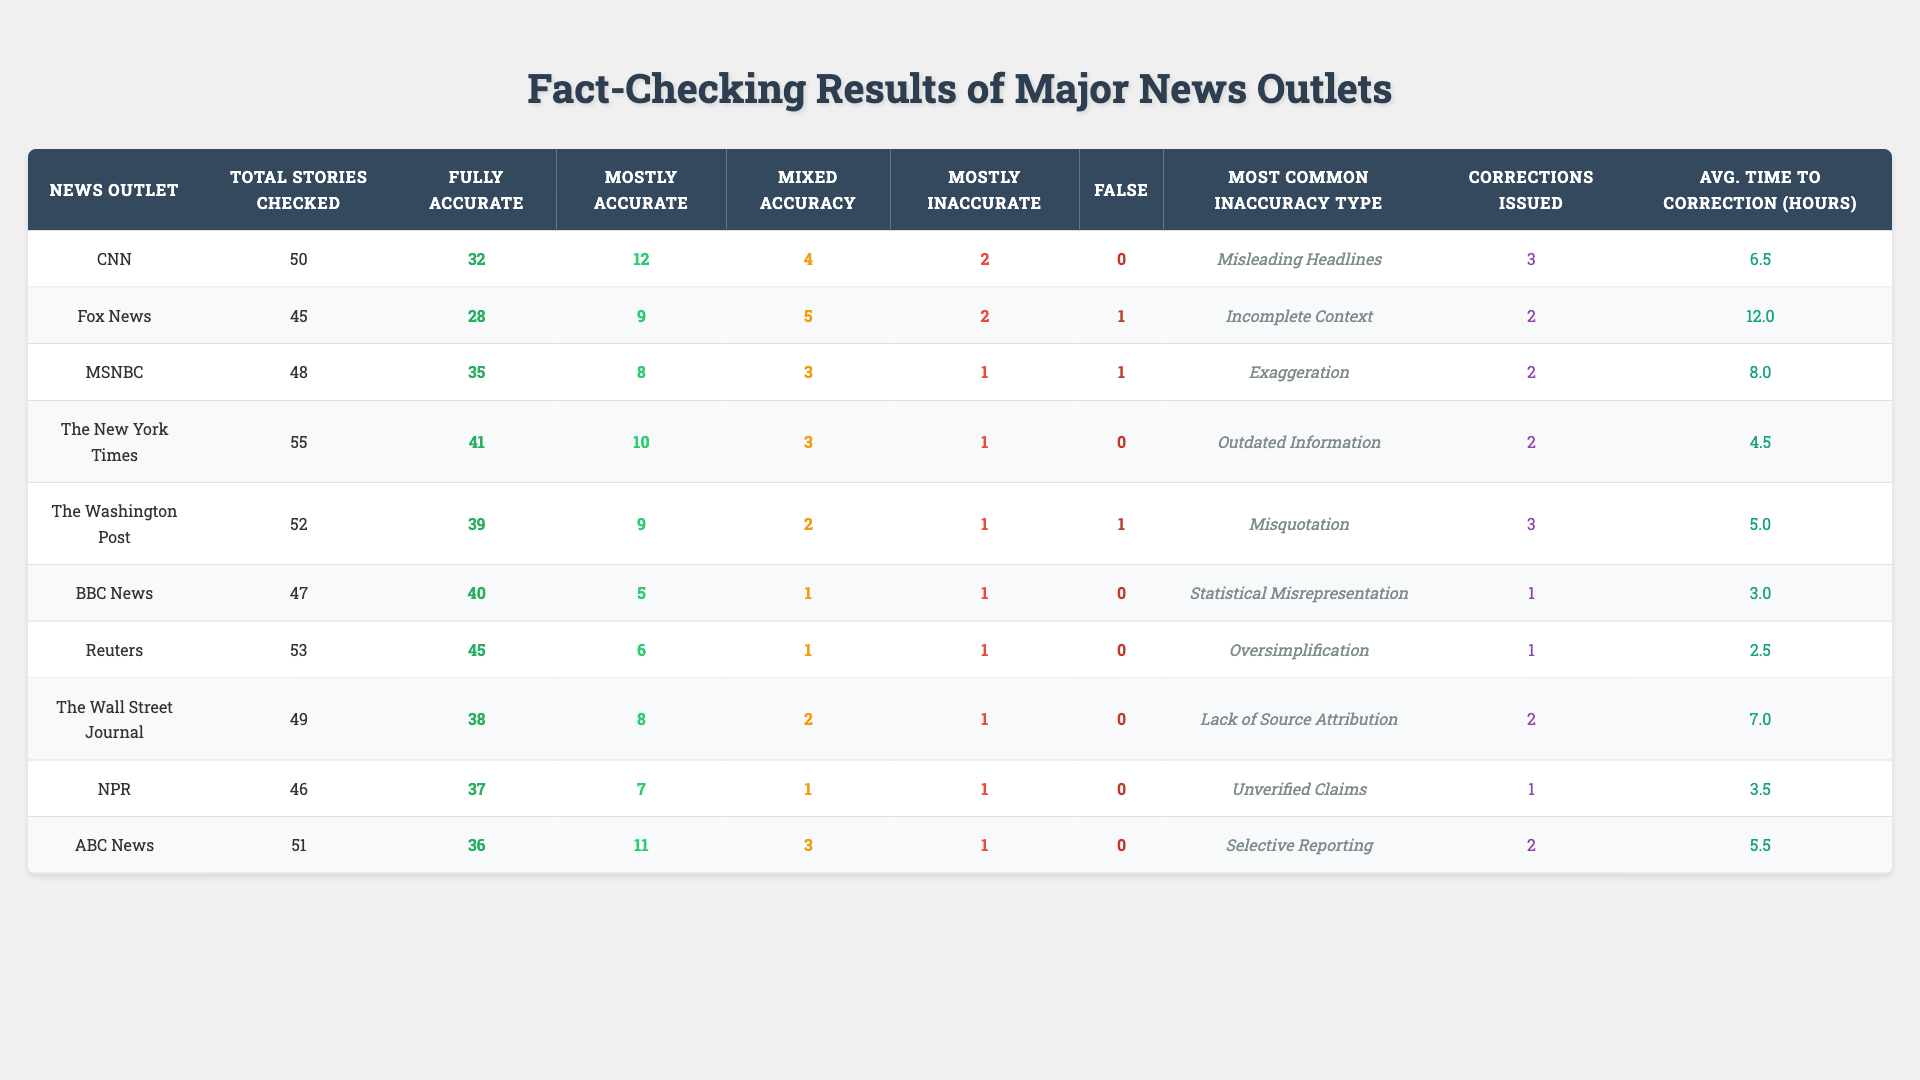What is the total number of stories checked by CNN? According to the table, CNN has a value of 50 under the "Total Stories Checked" column.
Answer: 50 Which news outlet had the highest number of fully accurate stories? Looking at the "Fully Accurate" column, The New York Times shows the highest number at 41.
Answer: The New York Times What is the average number of corrections issued across all the news outlets? To find the average, we sum the corrections issued (3+2+2+2+3+1+1+2+1+2 = 20) and divide by the number of outlets (10). So, 20/10 = 2.
Answer: 2 Which news outlet had the lowest average time to correction? The average time to correction is listed in the last column. The outlet with the lowest value is Reuters at 2.5 hours.
Answer: Reuters How many stories were rated as mostly inaccurate by MSNBC? According to the "Mostly Inaccurate" column, MSNBC has a count of 1 for mostly inaccurate stories.
Answer: 1 Which outlet reported the most incidents of misleading headlines? The "Most Common Inaccuracy Type" column indicates that CNN reported most of the misleading headlines.
Answer: CNN What is the difference in the number of fully accurate stories between The Wall Street Journal and BBC News? The Wall Street Journal has 38 fully accurate stories and BBC has 40. The difference is 40 - 38 = 2.
Answer: 2 How many stories did NPR check that were false? NPR's "False" column shows a count of 0 for false stories.
Answer: 0 Which outlet had the highest number of mixed accuracy stories? The "Mixed Accuracy" column shows that CNN had the highest count at 4.
Answer: CNN What is the median time for corrections to be issued among the news outlets? Sorting the average times to correction (2.5, 3.0, 3.5, 4.5, 5.0, 5.5, 6.5, 7.0, 8.0, 12.0) gives the median of 5.0 hours.
Answer: 5.0 hours Which news outlet has the highest total of stories checked compared to the lowest? The highest is The New York Times with 55 stories, and the lowest is Fox News with 45 stories, giving a difference of 55 - 45 = 10.
Answer: 10 How many corrections were issued by the news outlets that had more fully accurate stories than mostly accurate stories? Outlets with more fully accurate than mostly accurate (CNN, MSNBC, The New York Times, The Washington Post, BBC News, Reuters) issued corrections (3+2+2+3+1+1 = 12).
Answer: 12 